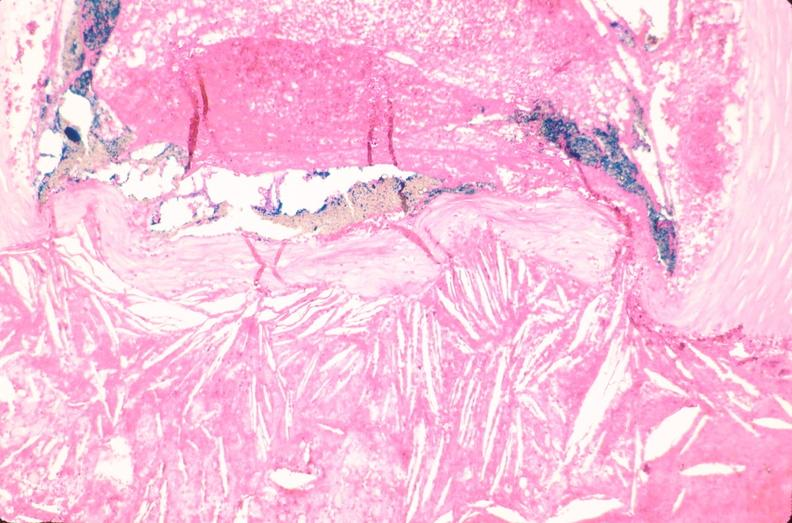where is this in?
Answer the question using a single word or phrase. In vasculature 